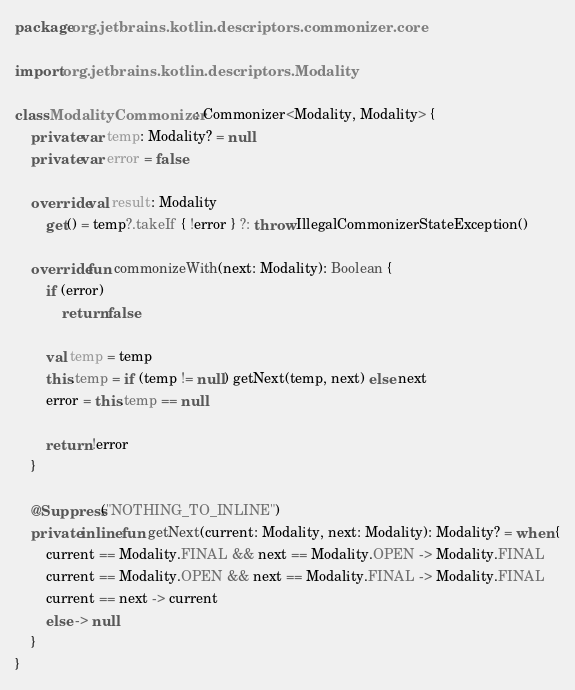<code> <loc_0><loc_0><loc_500><loc_500><_Kotlin_>package org.jetbrains.kotlin.descriptors.commonizer.core

import org.jetbrains.kotlin.descriptors.Modality

class ModalityCommonizer : Commonizer<Modality, Modality> {
    private var temp: Modality? = null
    private var error = false

    override val result: Modality
        get() = temp?.takeIf { !error } ?: throw IllegalCommonizerStateException()

    override fun commonizeWith(next: Modality): Boolean {
        if (error)
            return false

        val temp = temp
        this.temp = if (temp != null) getNext(temp, next) else next
        error = this.temp == null

        return !error
    }

    @Suppress("NOTHING_TO_INLINE")
    private inline fun getNext(current: Modality, next: Modality): Modality? = when {
        current == Modality.FINAL && next == Modality.OPEN -> Modality.FINAL
        current == Modality.OPEN && next == Modality.FINAL -> Modality.FINAL
        current == next -> current
        else -> null
    }
}
</code> 